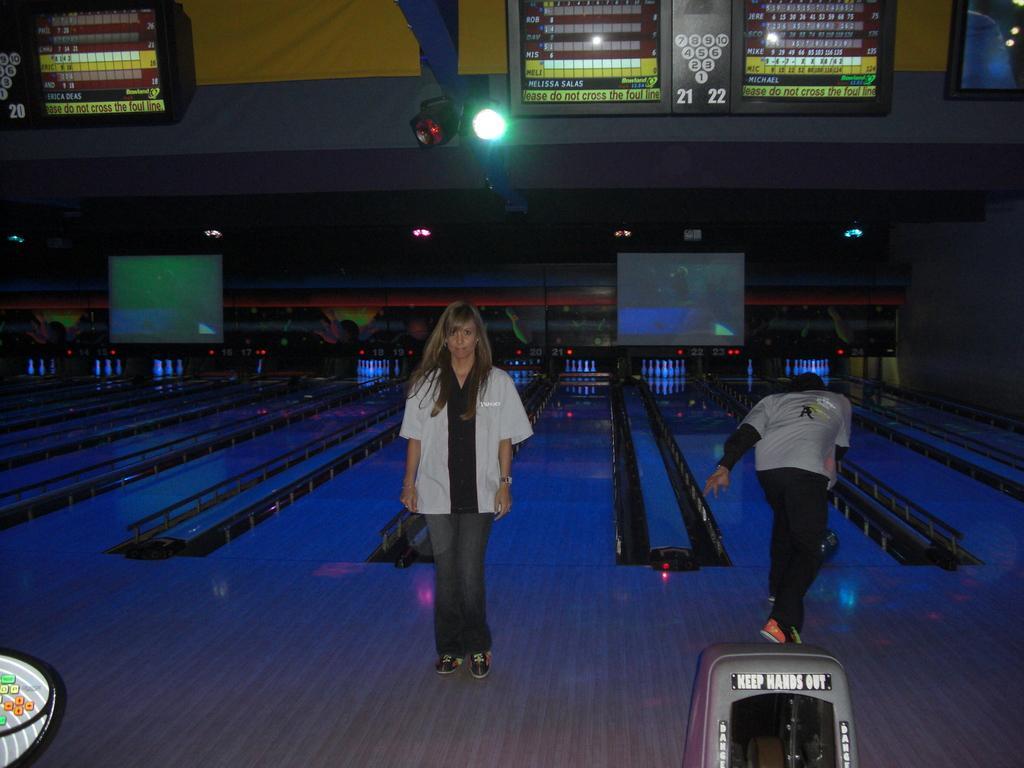Describe this image in one or two sentences. In the image there is a lady with white shirt is standing on the floor. Beside her there is a man bowling. In the background there are screens. At the top of the image there are screens with scores and also there are lights to the pillars. At the bottom of the image there is a machine. 